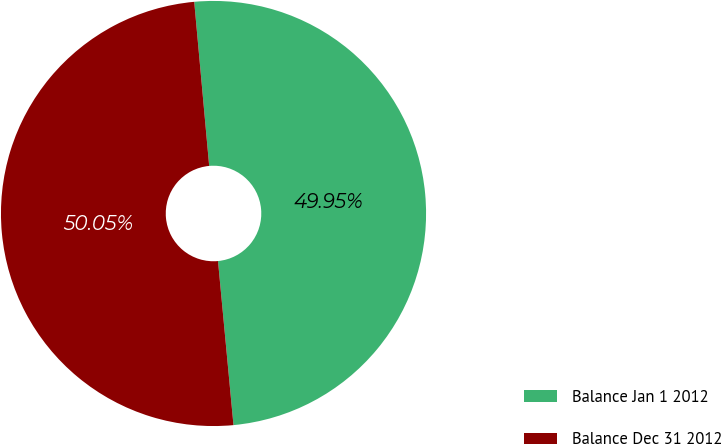<chart> <loc_0><loc_0><loc_500><loc_500><pie_chart><fcel>Balance Jan 1 2012<fcel>Balance Dec 31 2012<nl><fcel>49.95%<fcel>50.05%<nl></chart> 